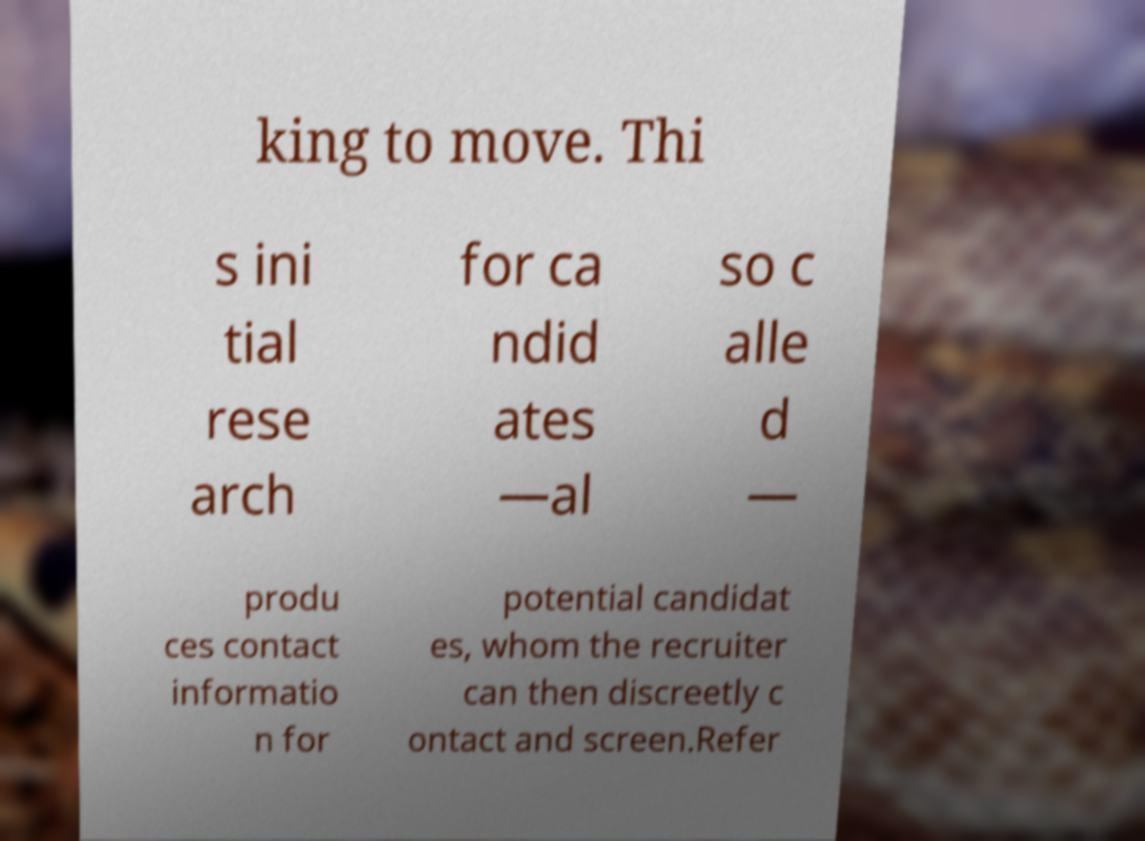Could you assist in decoding the text presented in this image and type it out clearly? king to move. Thi s ini tial rese arch for ca ndid ates —al so c alle d — produ ces contact informatio n for potential candidat es, whom the recruiter can then discreetly c ontact and screen.Refer 